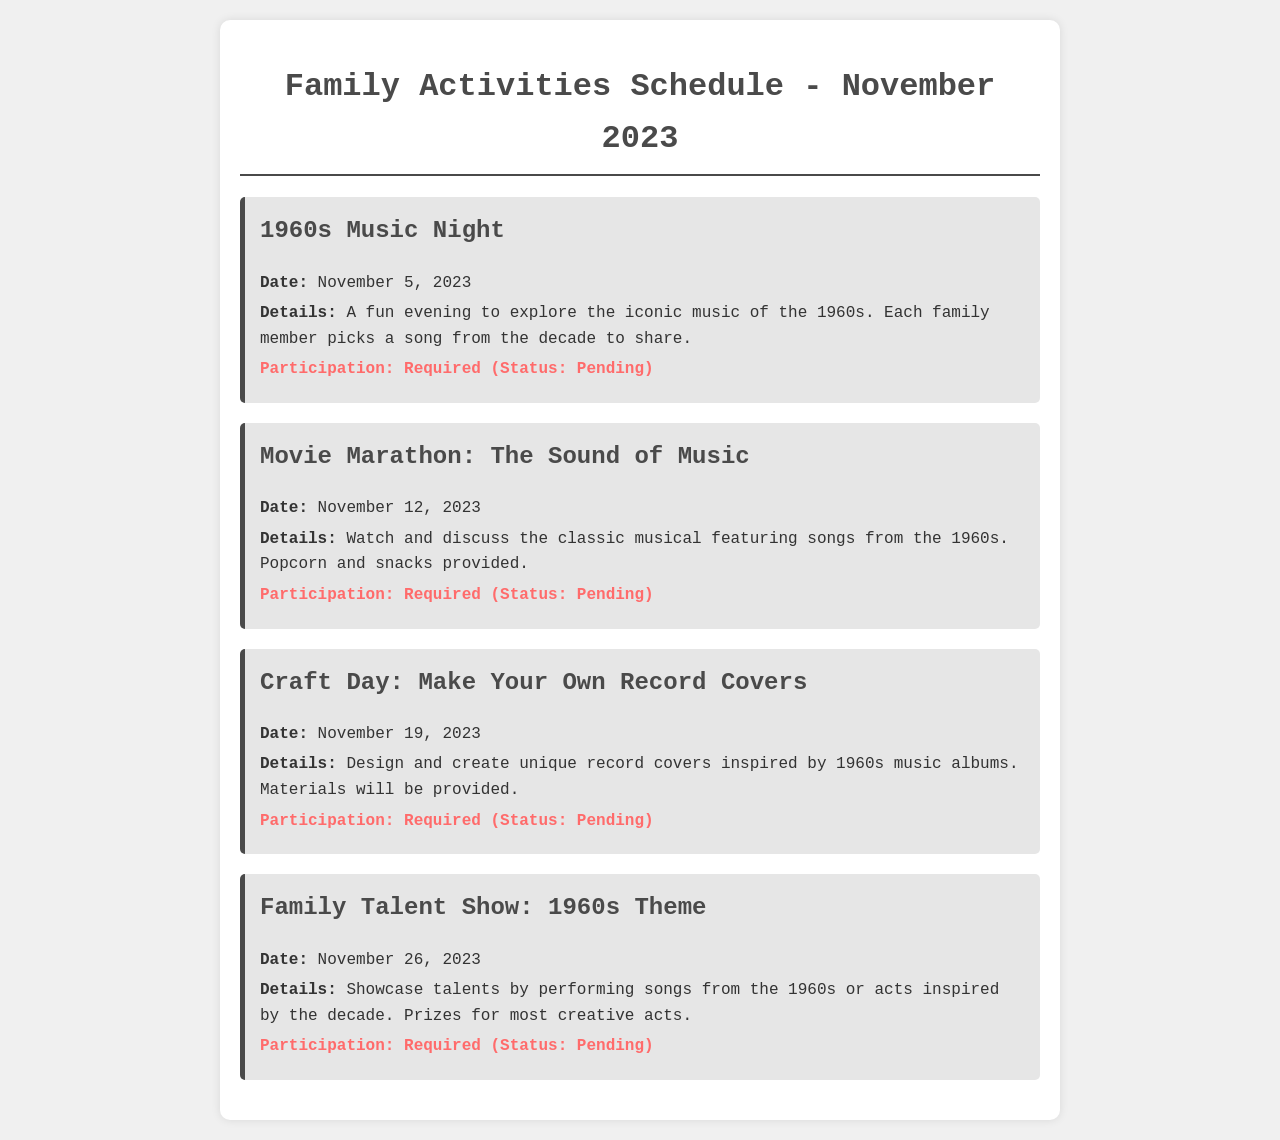What is the first activity listed? The first activity in the schedule is 1960s Music Night, which appears at the top of the document.
Answer: 1960s Music Night What is the date of the Movie Marathon? The date for the Movie Marathon activity can be found in the document under that event's details.
Answer: November 12, 2023 What materials will be provided for the Craft Day? The document mentions that materials will be provided for the Craft Day activity, which includes crafting activities.
Answer: Materials How many activities require participation? By counting the activities listed, all four events in the document specify that participation is required.
Answer: Four What is the theme of the Family Talent Show? The document specifies that the Family Talent Show is themed around the 1960s, highlighting its focus.
Answer: 1960s Theme What is the status of participation for all activities? Each activity's participation status is indicated as pending in the document, providing a clear overview of participation.
Answer: Pending 